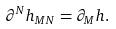Convert formula to latex. <formula><loc_0><loc_0><loc_500><loc_500>\partial ^ { N } h _ { M N } = \partial _ { M } h .</formula> 